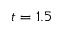<formula> <loc_0><loc_0><loc_500><loc_500>t = 1 . 5</formula> 